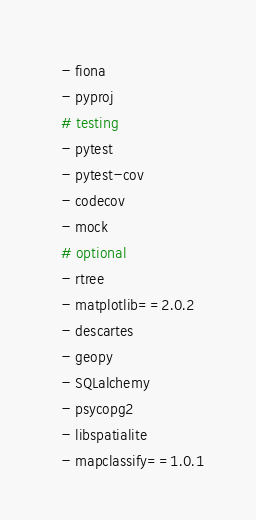Convert code to text. <code><loc_0><loc_0><loc_500><loc_500><_YAML_>  - fiona
  - pyproj
  # testing
  - pytest
  - pytest-cov
  - codecov
  - mock
  # optional
  - rtree
  - matplotlib==2.0.2
  - descartes
  - geopy
  - SQLalchemy
  - psycopg2
  - libspatialite
  - mapclassify==1.0.1
</code> 